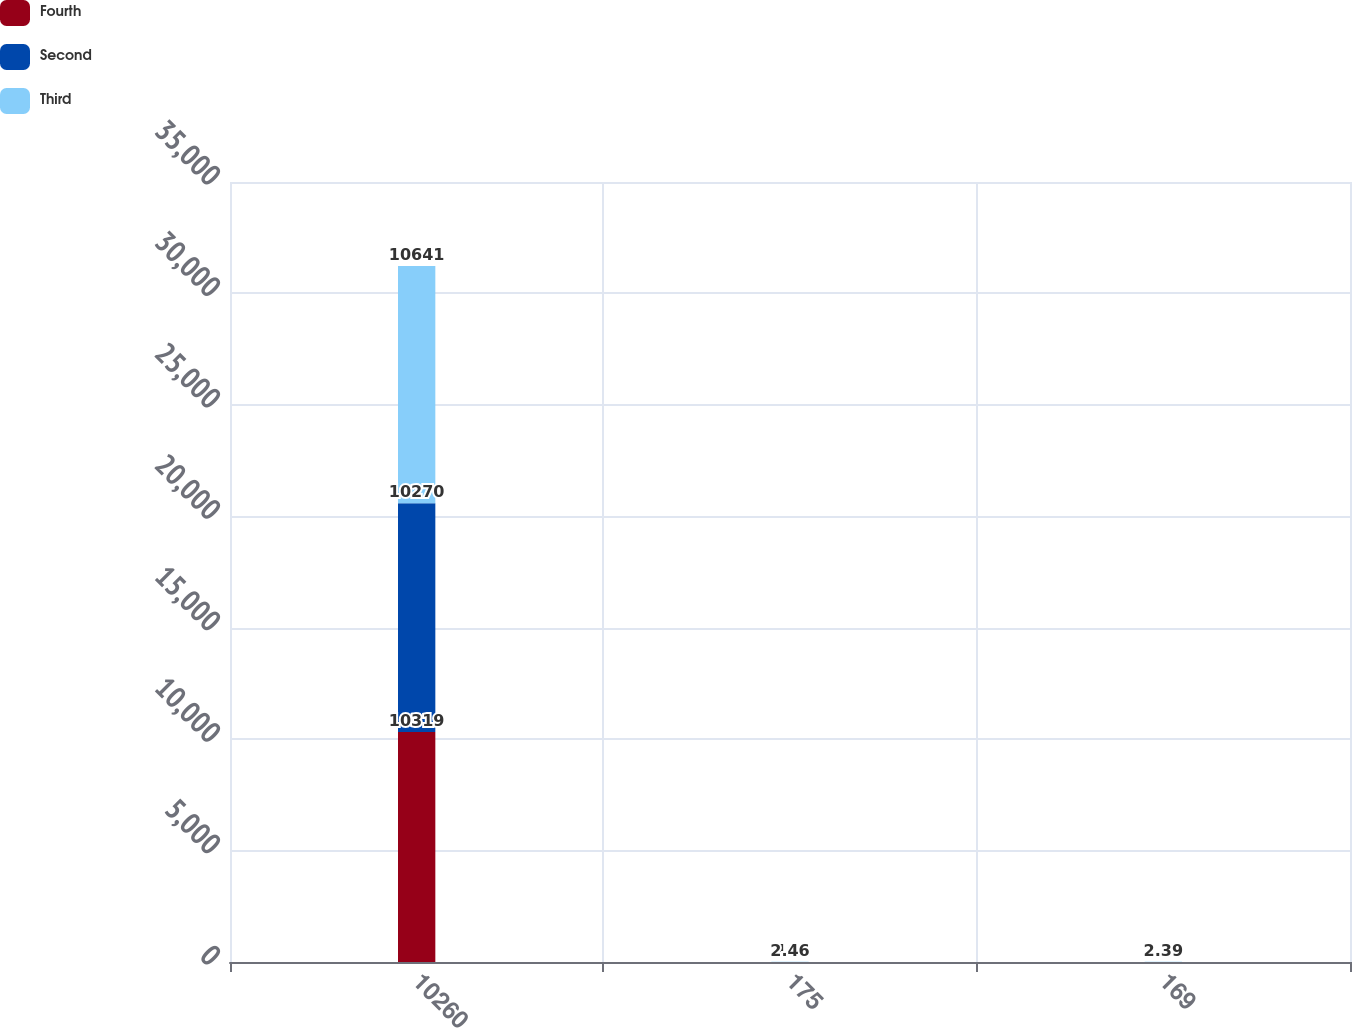Convert chart. <chart><loc_0><loc_0><loc_500><loc_500><stacked_bar_chart><ecel><fcel>10260<fcel>175<fcel>169<nl><fcel>Fourth<fcel>10319<fcel>1.7<fcel>1.65<nl><fcel>Second<fcel>10270<fcel>1.63<fcel>1.59<nl><fcel>Third<fcel>10641<fcel>2.46<fcel>2.39<nl></chart> 